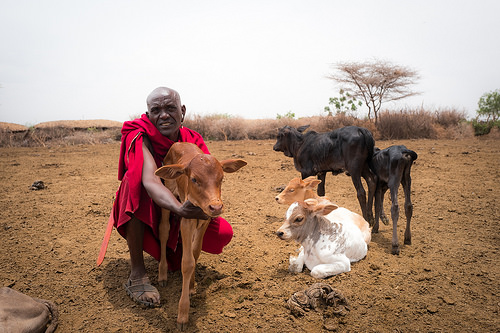<image>
Is there a cow behind the man? No. The cow is not behind the man. From this viewpoint, the cow appears to be positioned elsewhere in the scene. Is there a cow in front of the man? Yes. The cow is positioned in front of the man, appearing closer to the camera viewpoint. 